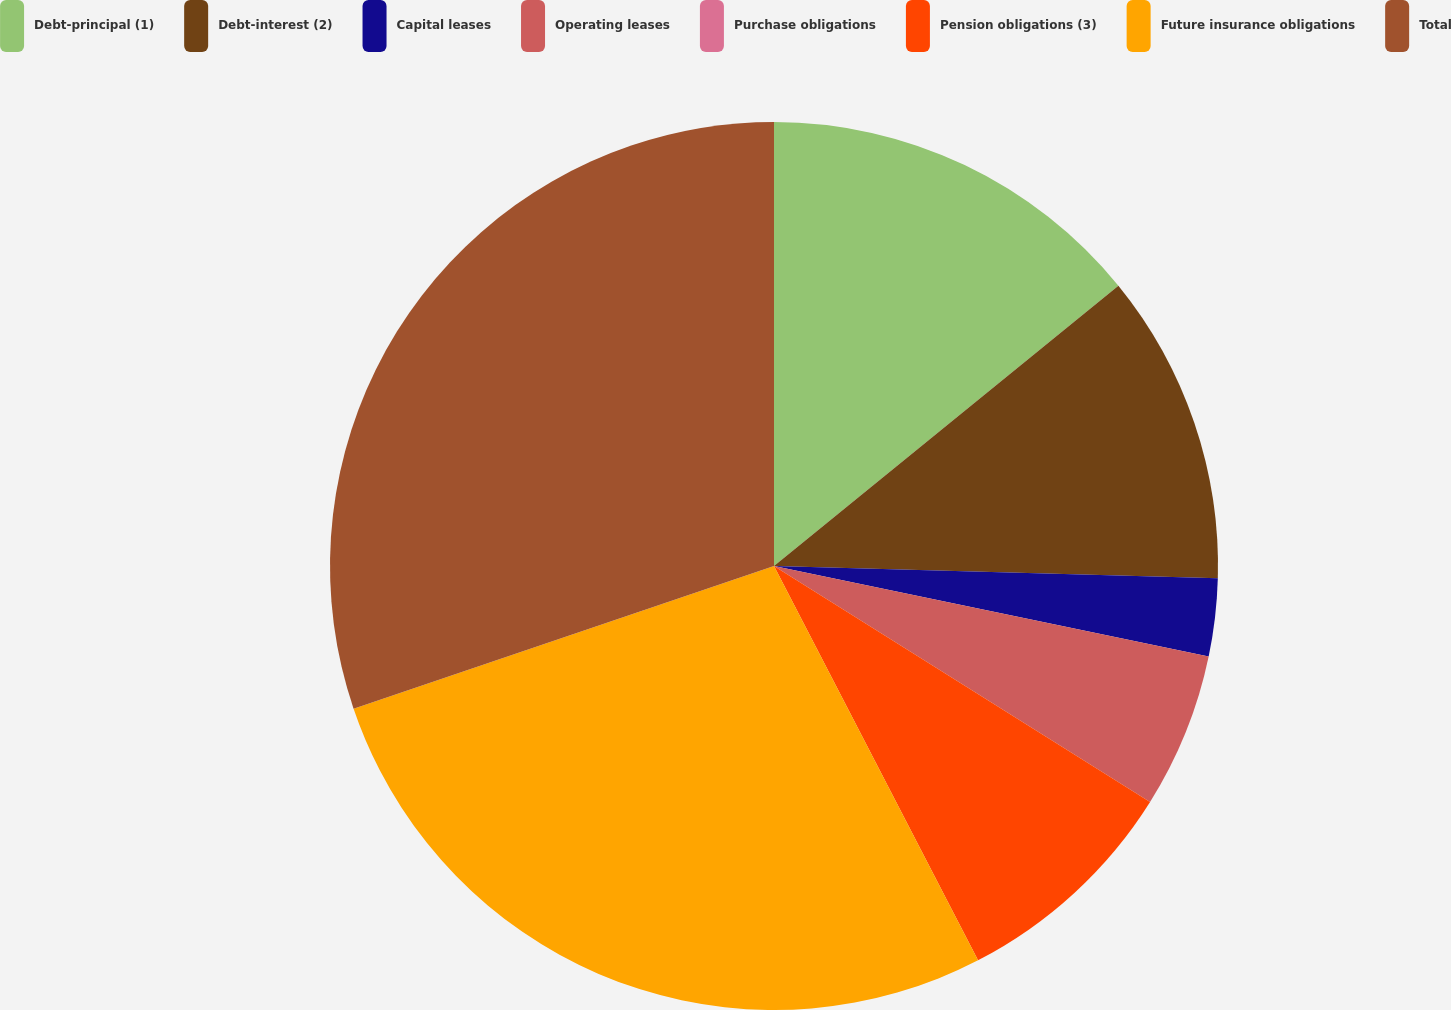Convert chart to OTSL. <chart><loc_0><loc_0><loc_500><loc_500><pie_chart><fcel>Debt-principal (1)<fcel>Debt-interest (2)<fcel>Capital leases<fcel>Operating leases<fcel>Purchase obligations<fcel>Pension obligations (3)<fcel>Future insurance obligations<fcel>Total<nl><fcel>14.13%<fcel>11.31%<fcel>2.83%<fcel>5.65%<fcel>0.0%<fcel>8.48%<fcel>27.39%<fcel>30.21%<nl></chart> 